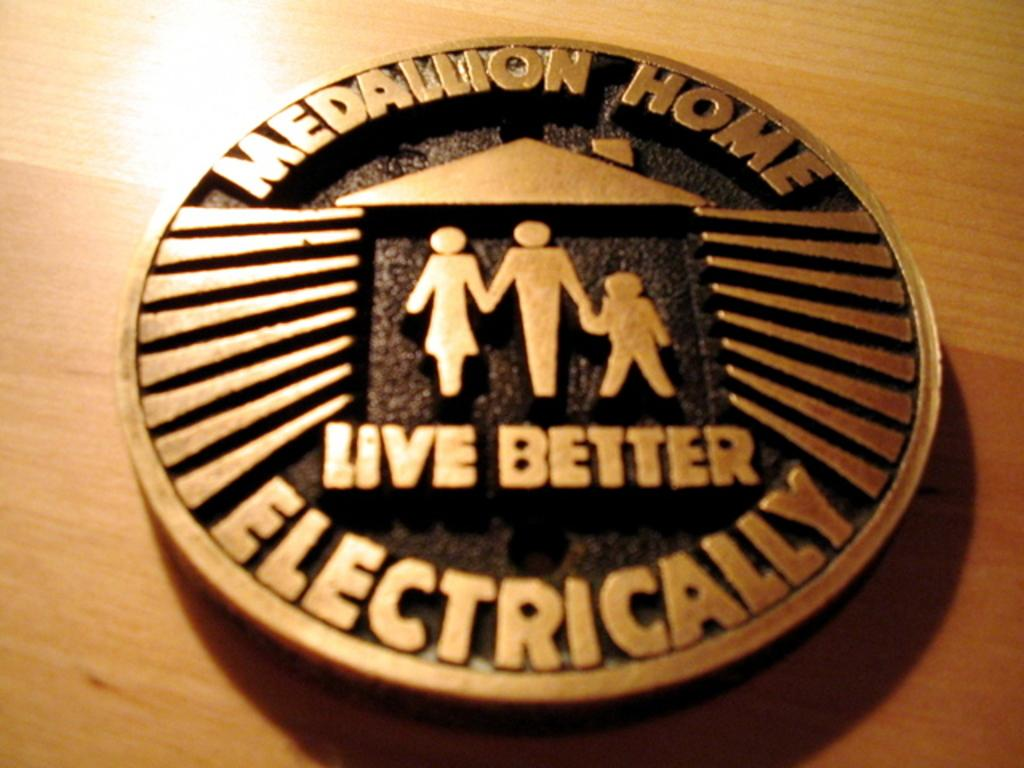What is depicted on the coin in the image? There are sculptures of persons on a coin. What else is present on the coin besides the sculptures? There are letters on the coin. Where is the coin located in the image? The coin is on a wooden surface. What type of rhythm can be heard coming from the downtown area in the image? There is no indication of a downtown area or any sounds in the image, so it's not possible to determine what rhythm might be heard. 